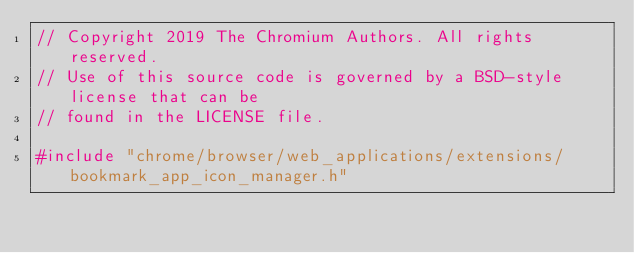Convert code to text. <code><loc_0><loc_0><loc_500><loc_500><_C++_>// Copyright 2019 The Chromium Authors. All rights reserved.
// Use of this source code is governed by a BSD-style license that can be
// found in the LICENSE file.

#include "chrome/browser/web_applications/extensions/bookmark_app_icon_manager.h"
</code> 